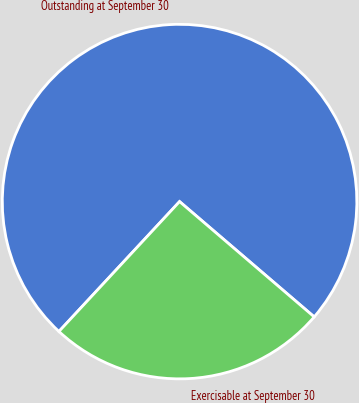<chart> <loc_0><loc_0><loc_500><loc_500><pie_chart><fcel>Outstanding at September 30<fcel>Exercisable at September 30<nl><fcel>74.36%<fcel>25.64%<nl></chart> 